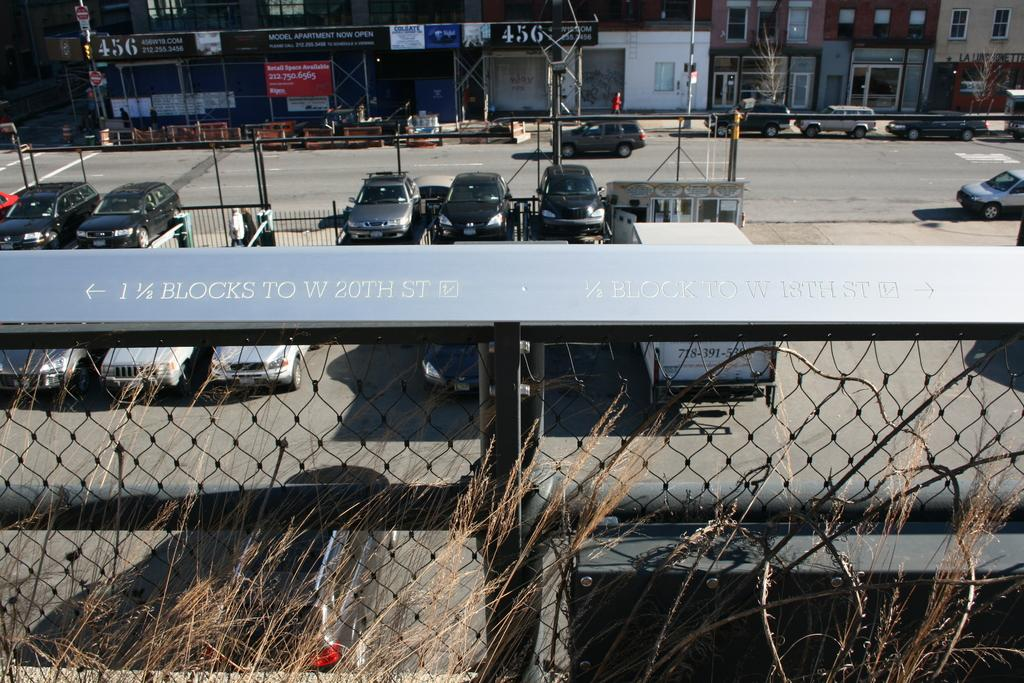What types of objects can be seen in the image? There are vehicles, people, buildings, trees, boards, and some objects in the image. Can you describe the vehicles in the image? The vehicles in the image are not specified, but they are present. What is the setting of the image? The image features a road with people, buildings, trees, and boards. What might the boards be used for? The boards in the image could be used for advertising, signage, or other purposes. How many boys are playing with the machine in the image? There is no machine or boys present in the image. 